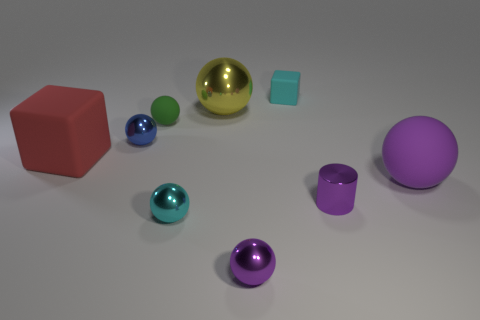Subtract all tiny blue balls. How many balls are left? 5 Add 1 large purple things. How many objects exist? 10 Subtract all cubes. How many objects are left? 7 Subtract all red blocks. How many blocks are left? 1 Subtract 5 spheres. How many spheres are left? 1 Subtract all cyan cubes. Subtract all cyan matte objects. How many objects are left? 7 Add 4 cylinders. How many cylinders are left? 5 Add 6 large yellow spheres. How many large yellow spheres exist? 7 Subtract 0 red cylinders. How many objects are left? 9 Subtract all green spheres. Subtract all cyan cylinders. How many spheres are left? 5 